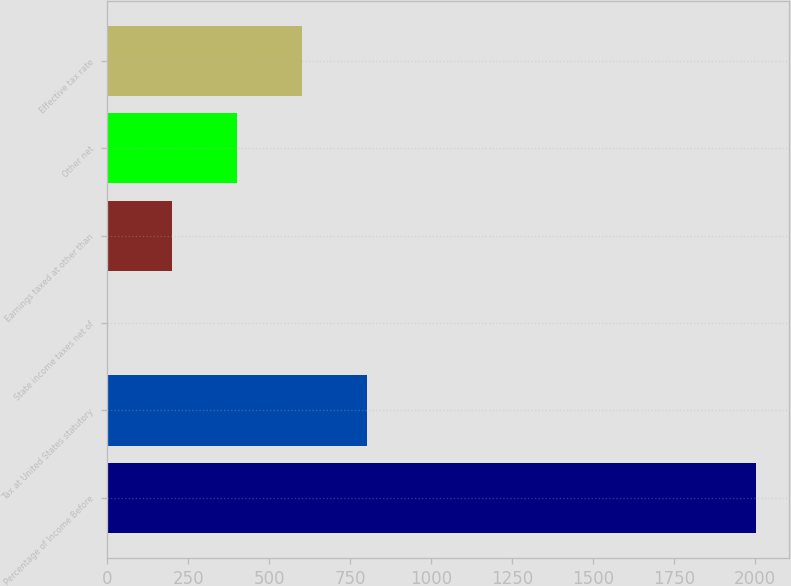Convert chart to OTSL. <chart><loc_0><loc_0><loc_500><loc_500><bar_chart><fcel>Percentage of Income Before<fcel>Tax at United States statutory<fcel>State income taxes net of<fcel>Earnings taxed at other than<fcel>Other net<fcel>Effective tax rate<nl><fcel>2004<fcel>802.2<fcel>1<fcel>201.3<fcel>401.6<fcel>601.9<nl></chart> 